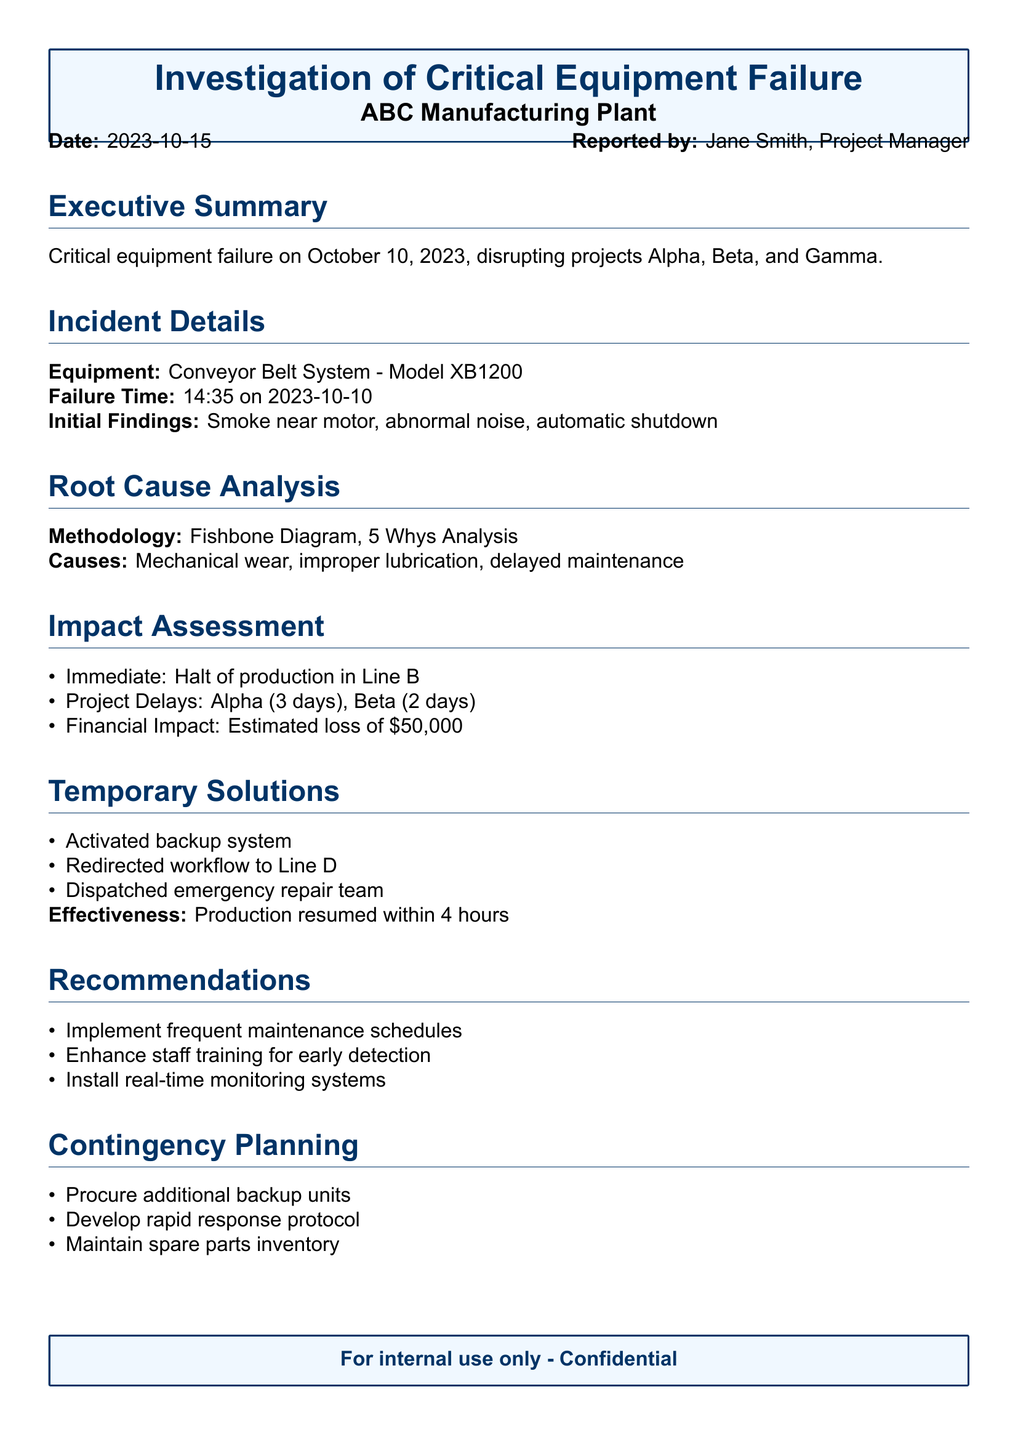What was the reported date of the incident? The incident report states the date of the incident as October 15, 2023.
Answer: October 15, 2023 What type of equipment failed? The document specifies that the equipment that failed was a Conveyor Belt System.
Answer: Conveyor Belt System What was the estimated financial impact of the incident? The financial impact is directly stated in the document as an estimated loss due to the incident.
Answer: $50,000 How long was the production halted in Line B? The impact assessment details that there was a halt in production in Line B, directly indicating a timeframe.
Answer: Immediate What solutions were implemented temporarily? The report lists the temporary solutions activated during the incident, including activating a backup system.
Answer: Activated backup system What methodology was used for the root cause analysis? The document specifically mentions the methodologies used for analyzing the root cause of the incident.
Answer: Fishbone Diagram, 5 Whys Analysis What was the impact on project Alpha in terms of days? The impact assessment includes specific delays to different projects, including the delay for project Alpha.
Answer: 3 days What does the report recommend for future prevention? The recommendations section of the document outlines preventive measures for future incidents.
Answer: Implement frequent maintenance schedules How long did it take for production to resume after the incident? The effectiveness of the temporary solutions is described in the document, indicating how quickly production resumed.
Answer: 4 hours 